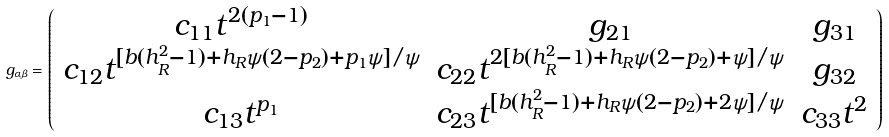<formula> <loc_0><loc_0><loc_500><loc_500>g _ { \alpha \beta } = \left ( \begin{array} { c c c } c _ { 1 1 } t ^ { 2 ( p _ { 1 } - 1 ) } & g _ { 2 1 } & g _ { 3 1 } \\ c _ { 1 2 } t ^ { [ b ( h _ { R } ^ { 2 } - 1 ) + h _ { R } \psi ( 2 - p _ { 2 } ) + p _ { 1 } \psi ] / \psi } & c _ { 2 2 } t ^ { 2 [ b ( h _ { R } ^ { 2 } - 1 ) + h _ { R } \psi ( 2 - p _ { 2 } ) + \psi ] / \psi } & g _ { 3 2 } \\ c _ { 1 3 } t ^ { p _ { 1 } } & c _ { 2 3 } t ^ { [ b ( h _ { R } ^ { 2 } - 1 ) + h _ { R } \psi ( 2 - p _ { 2 } ) + 2 \psi ] / \psi } & c _ { 3 3 } t ^ { 2 } \end{array} \right )</formula> 